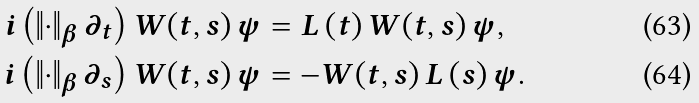<formula> <loc_0><loc_0><loc_500><loc_500>i \left ( \left \| \cdot \right \| _ { \beta } \partial _ { t } \right ) W _ { } \left ( t , s \right ) \psi & = L _ { } \left ( t \right ) W _ { } \left ( t , s \right ) \psi , \\ i \left ( \left \| \cdot \right \| _ { \beta } \partial _ { s } \right ) W _ { } \left ( t , s \right ) \psi & = - W _ { } \left ( t , s \right ) L _ { } \left ( s \right ) \psi .</formula> 